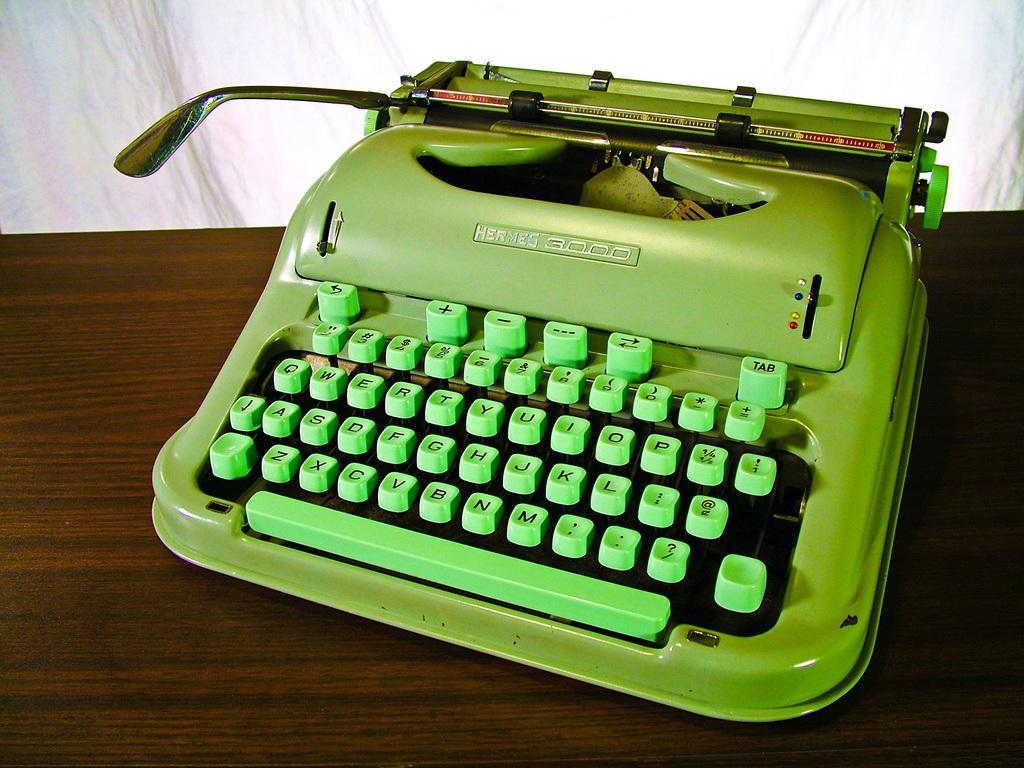Provide a one-sentence caption for the provided image. a typewriter that has the name Hermes at the top. 